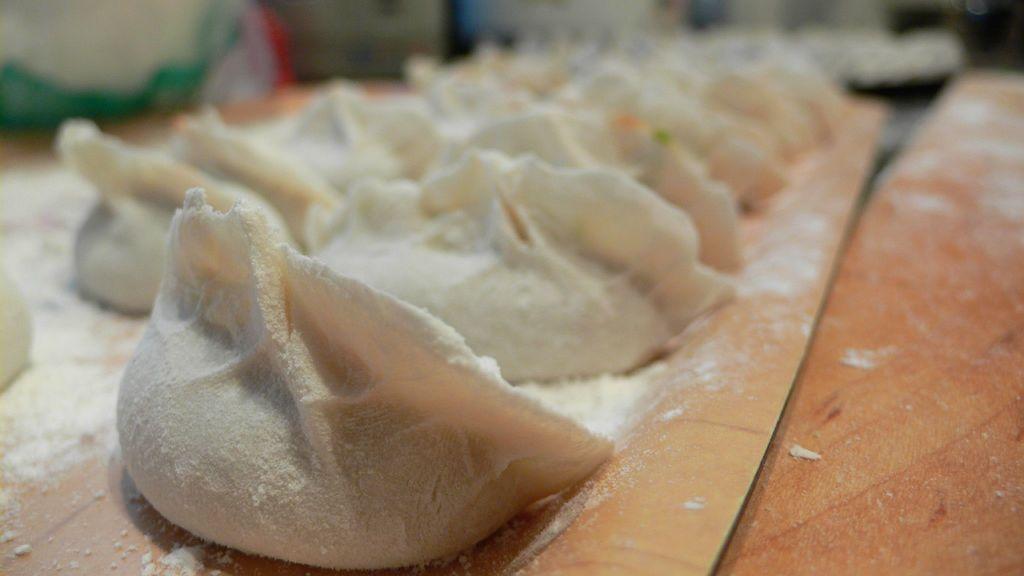How would you summarize this image in a sentence or two? In the image there are raw flour snacks. These snacks are on the brown color surface. 